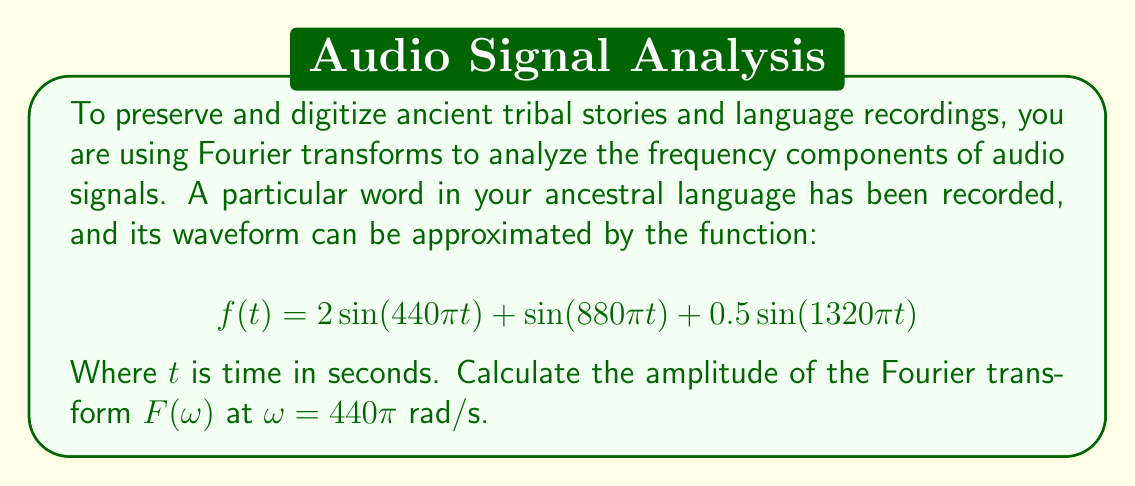Can you answer this question? To solve this problem, we need to understand the Fourier transform and how it applies to our given function. The Fourier transform of a continuous-time signal $f(t)$ is given by:

$$F(\omega) = \int_{-\infty}^{\infty} f(t) e^{-i\omega t} dt$$

In our case, $f(t)$ is a sum of sine waves with different frequencies and amplitudes. The Fourier transform of a sine wave has a specific property:

For $f(t) = A\sin(\omega_0 t)$, the Fourier transform is:

$$F(\omega) = i\pi A[\delta(\omega - \omega_0) - \delta(\omega + \omega_0)]$$

Where $\delta$ is the Dirac delta function.

Now, let's break down our function:

1. $2\sin(440\pi t)$ has amplitude 2 and frequency $440\pi$ rad/s
2. $\sin(880\pi t)$ has amplitude 1 and frequency $880\pi$ rad/s
3. $0.5\sin(1320\pi t)$ has amplitude 0.5 and frequency $1320\pi$ rad/s

We're asked to find the amplitude at $\omega = 440\pi$ rad/s, which corresponds to the first term in our function. The other terms will not contribute to the amplitude at this frequency.

For the term $2\sin(440\pi t)$, the Fourier transform will have an amplitude of $2\pi$ at $\omega = 440\pi$ rad/s (and $-440\pi$ rad/s, but we're only concerned with the positive frequency).

Therefore, the amplitude of the Fourier transform $F(\omega)$ at $\omega = 440\pi$ rad/s is $2\pi$.
Answer: $2\pi$ 